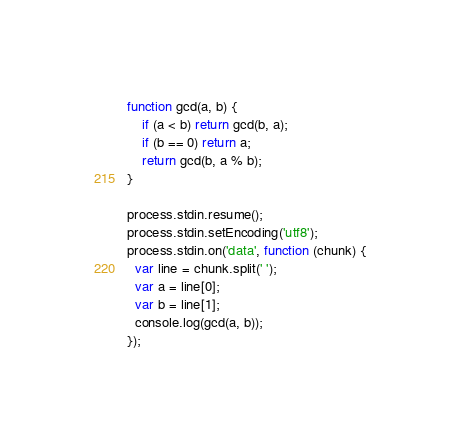Convert code to text. <code><loc_0><loc_0><loc_500><loc_500><_JavaScript_>function gcd(a, b) {
	if (a < b) return gcd(b, a);
	if (b == 0) return a;
	return gcd(b, a % b);
}

process.stdin.resume();
process.stdin.setEncoding('utf8');
process.stdin.on('data', function (chunk) {
  var line = chunk.split(' ');
  var a = line[0];
  var b = line[1];
  console.log(gcd(a, b));
});</code> 